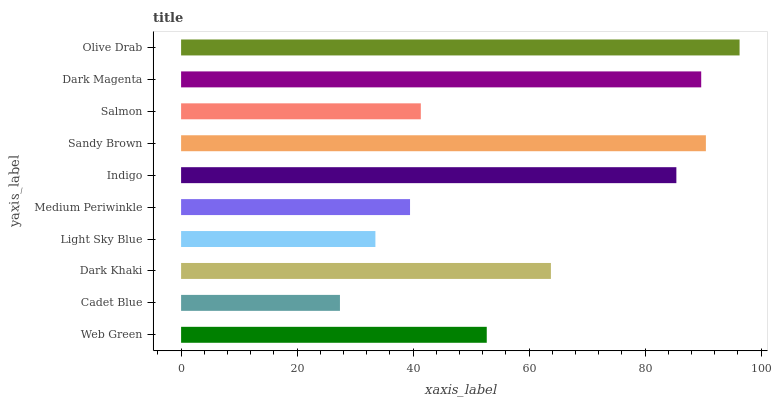Is Cadet Blue the minimum?
Answer yes or no. Yes. Is Olive Drab the maximum?
Answer yes or no. Yes. Is Dark Khaki the minimum?
Answer yes or no. No. Is Dark Khaki the maximum?
Answer yes or no. No. Is Dark Khaki greater than Cadet Blue?
Answer yes or no. Yes. Is Cadet Blue less than Dark Khaki?
Answer yes or no. Yes. Is Cadet Blue greater than Dark Khaki?
Answer yes or no. No. Is Dark Khaki less than Cadet Blue?
Answer yes or no. No. Is Dark Khaki the high median?
Answer yes or no. Yes. Is Web Green the low median?
Answer yes or no. Yes. Is Cadet Blue the high median?
Answer yes or no. No. Is Sandy Brown the low median?
Answer yes or no. No. 